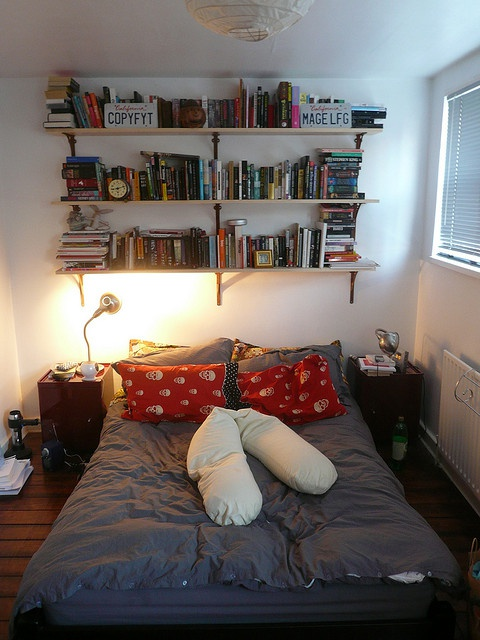Describe the objects in this image and their specific colors. I can see bed in gray, black, maroon, and darkgray tones, book in gray, black, maroon, and darkgray tones, bottle in gray, black, and darkgreen tones, book in gray, darkgray, maroon, and brown tones, and clock in gray and olive tones in this image. 